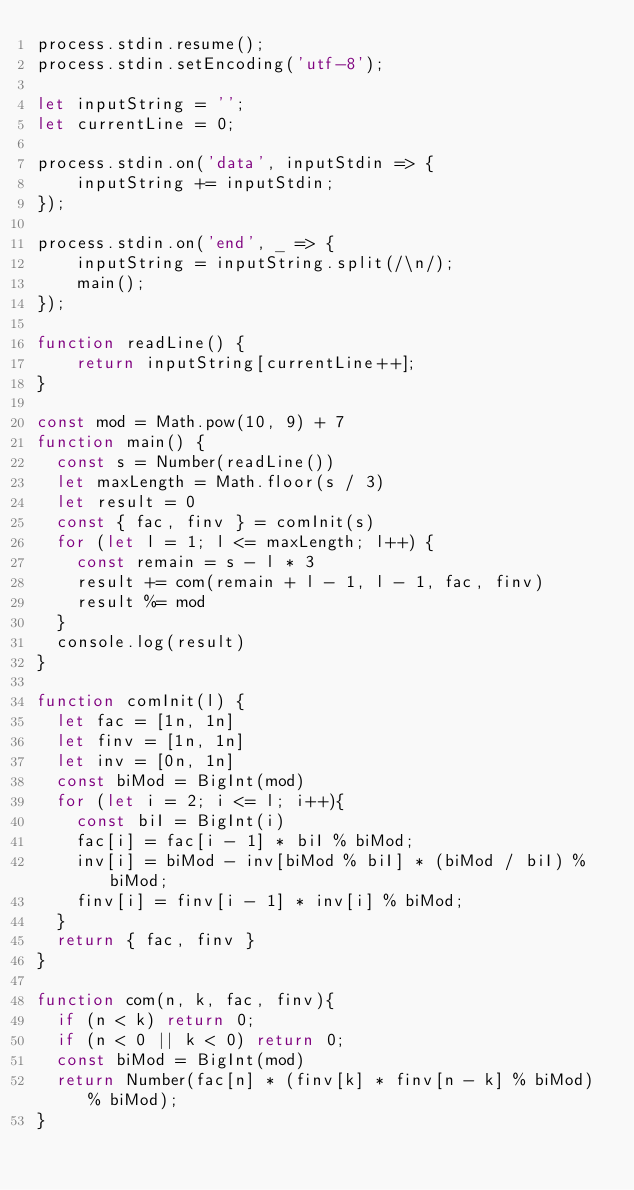Convert code to text. <code><loc_0><loc_0><loc_500><loc_500><_JavaScript_>process.stdin.resume();
process.stdin.setEncoding('utf-8');
 
let inputString = '';
let currentLine = 0;
 
process.stdin.on('data', inputStdin => {
    inputString += inputStdin;
});
 
process.stdin.on('end', _ => {
    inputString = inputString.split(/\n/);
    main();    
});
 
function readLine() {
    return inputString[currentLine++];
}

const mod = Math.pow(10, 9) + 7
function main() {
  const s = Number(readLine())
  let maxLength = Math.floor(s / 3)
  let result = 0
  const { fac, finv } = comInit(s)
  for (let l = 1; l <= maxLength; l++) {
    const remain = s - l * 3
    result += com(remain + l - 1, l - 1, fac, finv)
    result %= mod
  }
  console.log(result)
}

function comInit(l) {
  let fac = [1n, 1n]
  let finv = [1n, 1n]
  let inv = [0n, 1n]
  const biMod = BigInt(mod)
  for (let i = 2; i <= l; i++){
    const biI = BigInt(i)
    fac[i] = fac[i - 1] * biI % biMod;
    inv[i] = biMod - inv[biMod % biI] * (biMod / biI) % biMod;
    finv[i] = finv[i - 1] * inv[i] % biMod;
  }
  return { fac, finv }
}

function com(n, k, fac, finv){
  if (n < k) return 0;
  if (n < 0 || k < 0) return 0;
  const biMod = BigInt(mod)
  return Number(fac[n] * (finv[k] * finv[n - k] % biMod) % biMod);
}</code> 